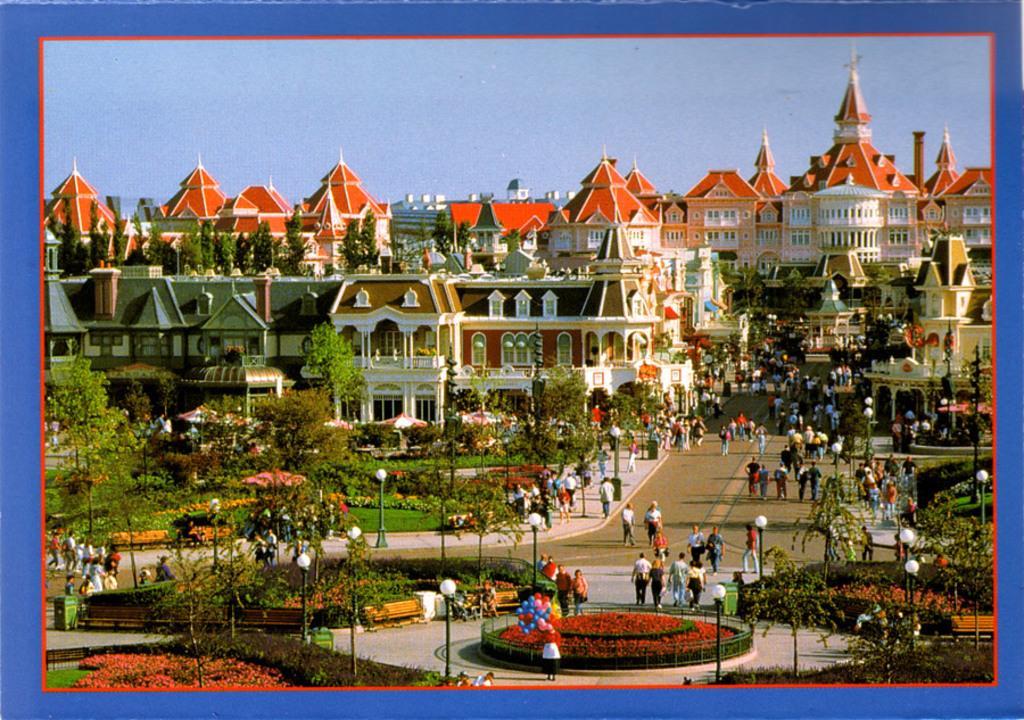Please provide a concise description of this image. In the picture we can see a photograph with blue color borders to it and in the photograph we can see a garden with grass surface, plants, poles and lights to it and some people walking on the path and some are standing and talking to each other and in the background we can see many buildings with pillars and windows in it and behind it we can see a sky. 